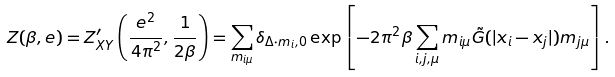Convert formula to latex. <formula><loc_0><loc_0><loc_500><loc_500>Z ( \beta , e ) = Z ^ { \prime } _ { X Y } \left ( \frac { e ^ { 2 } } { 4 \pi ^ { 2 } } , \frac { 1 } { 2 \beta } \right ) = \sum _ { m _ { i \mu } } \delta _ { { \Delta } \cdot { m } _ { i } , 0 } \exp \left [ - 2 \pi ^ { 2 } \beta \sum _ { i , j , \mu } m _ { i \mu } \tilde { G } ( | { x } _ { i } - { x } _ { j } | ) m _ { j \mu } \right ] .</formula> 